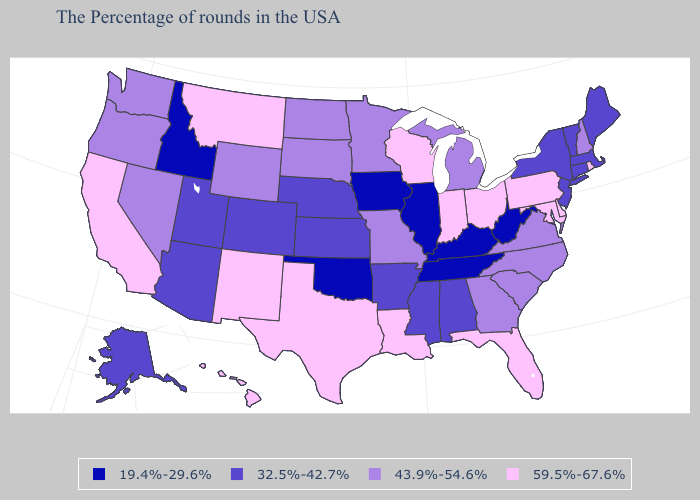What is the value of Idaho?
Write a very short answer. 19.4%-29.6%. Name the states that have a value in the range 59.5%-67.6%?
Short answer required. Rhode Island, Delaware, Maryland, Pennsylvania, Ohio, Florida, Indiana, Wisconsin, Louisiana, Texas, New Mexico, Montana, California, Hawaii. Does the first symbol in the legend represent the smallest category?
Concise answer only. Yes. Does Alabama have the same value as Connecticut?
Answer briefly. Yes. Name the states that have a value in the range 43.9%-54.6%?
Keep it brief. New Hampshire, Virginia, North Carolina, South Carolina, Georgia, Michigan, Missouri, Minnesota, South Dakota, North Dakota, Wyoming, Nevada, Washington, Oregon. Among the states that border Kentucky , does West Virginia have the highest value?
Short answer required. No. Name the states that have a value in the range 32.5%-42.7%?
Short answer required. Maine, Massachusetts, Vermont, Connecticut, New York, New Jersey, Alabama, Mississippi, Arkansas, Kansas, Nebraska, Colorado, Utah, Arizona, Alaska. What is the lowest value in states that border Missouri?
Keep it brief. 19.4%-29.6%. What is the value of South Dakota?
Give a very brief answer. 43.9%-54.6%. Name the states that have a value in the range 32.5%-42.7%?
Answer briefly. Maine, Massachusetts, Vermont, Connecticut, New York, New Jersey, Alabama, Mississippi, Arkansas, Kansas, Nebraska, Colorado, Utah, Arizona, Alaska. Among the states that border Montana , does Idaho have the lowest value?
Short answer required. Yes. Which states hav the highest value in the West?
Short answer required. New Mexico, Montana, California, Hawaii. What is the value of Delaware?
Be succinct. 59.5%-67.6%. Which states have the highest value in the USA?
Be succinct. Rhode Island, Delaware, Maryland, Pennsylvania, Ohio, Florida, Indiana, Wisconsin, Louisiana, Texas, New Mexico, Montana, California, Hawaii. 